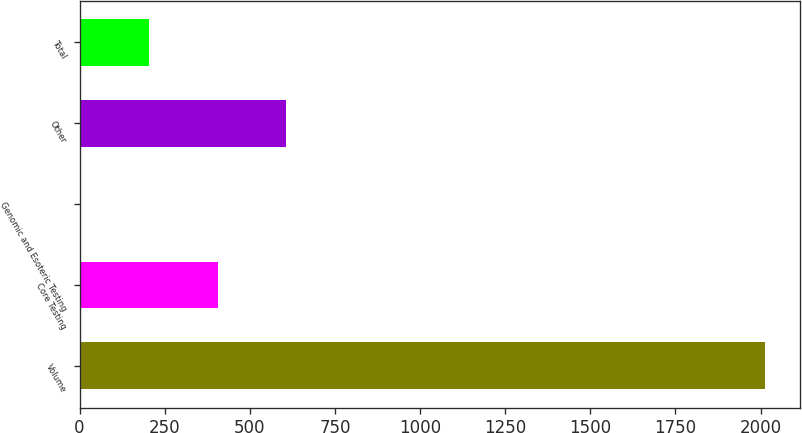Convert chart to OTSL. <chart><loc_0><loc_0><loc_500><loc_500><bar_chart><fcel>Volume<fcel>Core Testing<fcel>Genomic and Esoteric Testing<fcel>Other<fcel>Total<nl><fcel>2014<fcel>406.32<fcel>4.4<fcel>607.28<fcel>205.36<nl></chart> 